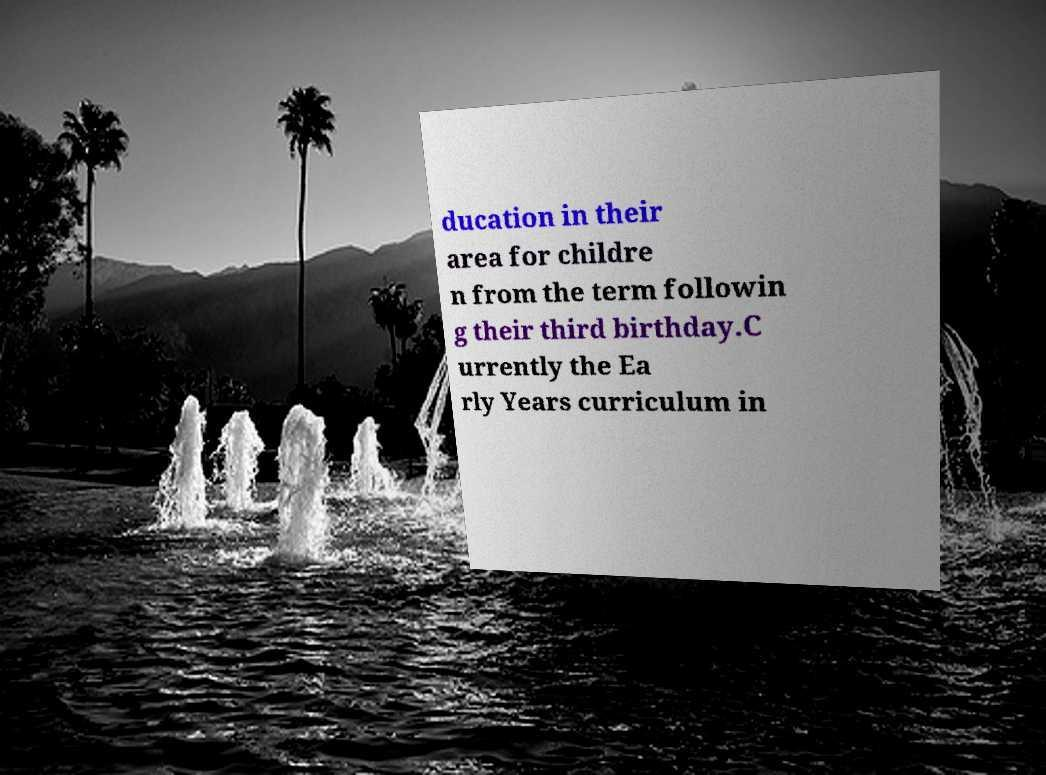Can you accurately transcribe the text from the provided image for me? ducation in their area for childre n from the term followin g their third birthday.C urrently the Ea rly Years curriculum in 